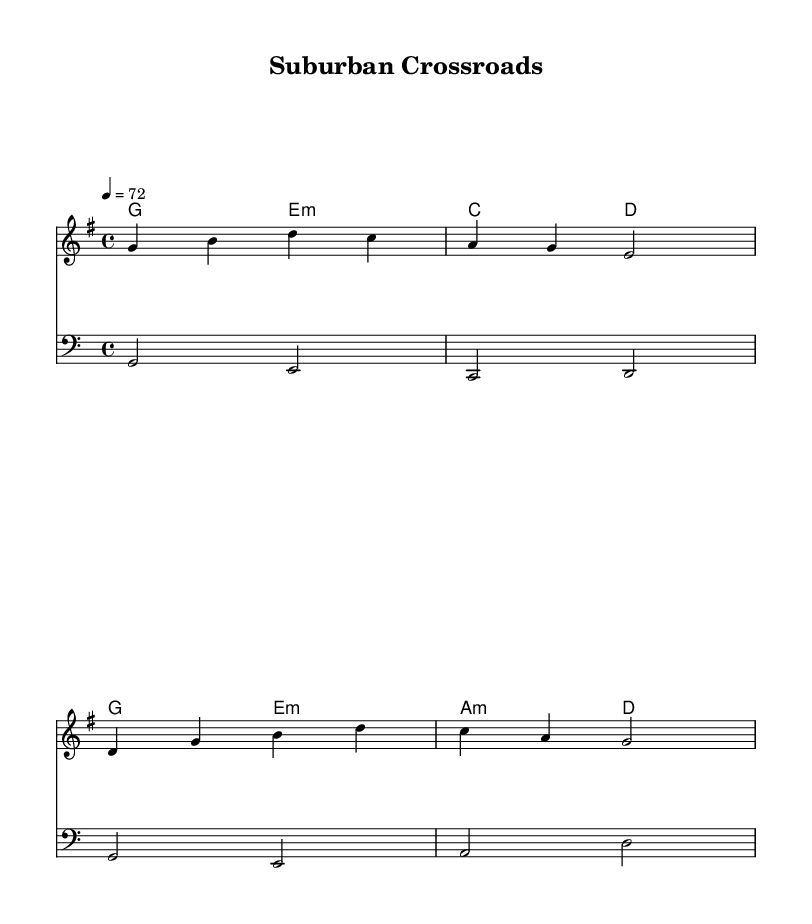What is the key signature of this music? The key signature is G major, indicated by one sharp (F#) which is notated at the beginning of the score.
Answer: G major What is the time signature of this music? The time signature is 4/4, shown at the beginning of the score, which means there are four beats in each measure and a quarter note gets one beat.
Answer: 4/4 What is the tempo marking of this music? The tempo marking indicates a pace of 72 beats per minute. This is shown by the number "4 = 72" under the tempo indication, clarifying the speed of the piece.
Answer: 72 What is the first chord in the chord progression? The first chord in the harmonies is G major, which is indicated at the beginning of the harmonies section. The chord G is written in the chord mode notation.
Answer: G How many measures are there in the melody? The melody consists of four measures, as evidenced by the grouping of notes into four distinct segments, each separated by a bar line.
Answer: 4 What thematic element is reflected in the lyrics? The lyrics reflect themes of nostalgia and life changes, as they evoke memories of past experiences, suggesting personal growth over time. This is evident in phrases describing fading city lights and reminiscing about knowledge of the past.
Answer: Nostalgia 